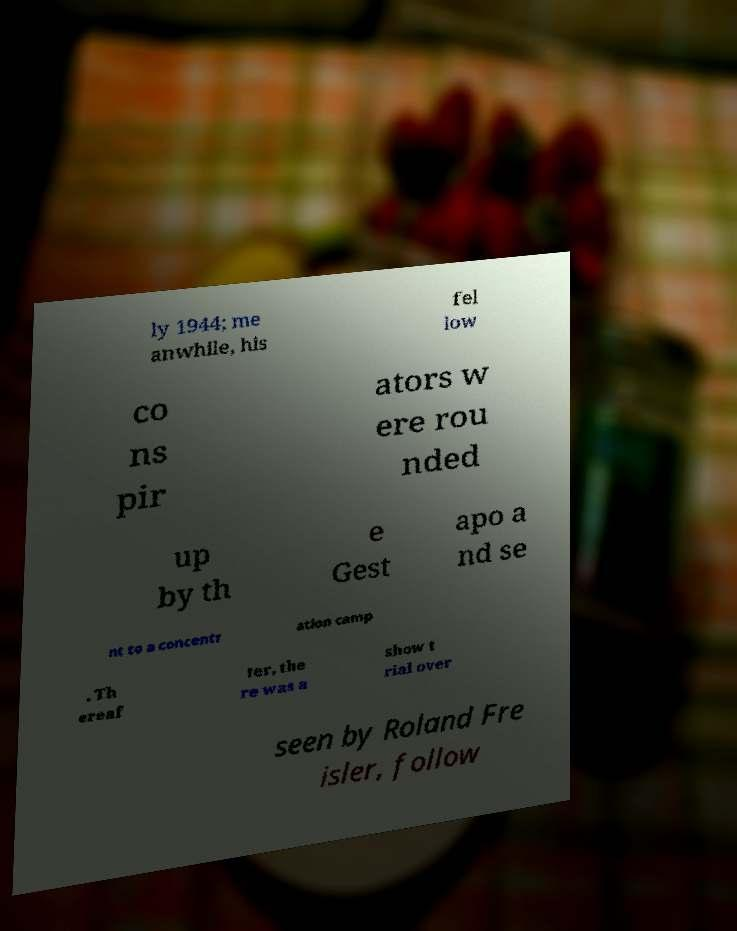I need the written content from this picture converted into text. Can you do that? ly 1944; me anwhile, his fel low co ns pir ators w ere rou nded up by th e Gest apo a nd se nt to a concentr ation camp . Th ereaf ter, the re was a show t rial over seen by Roland Fre isler, follow 